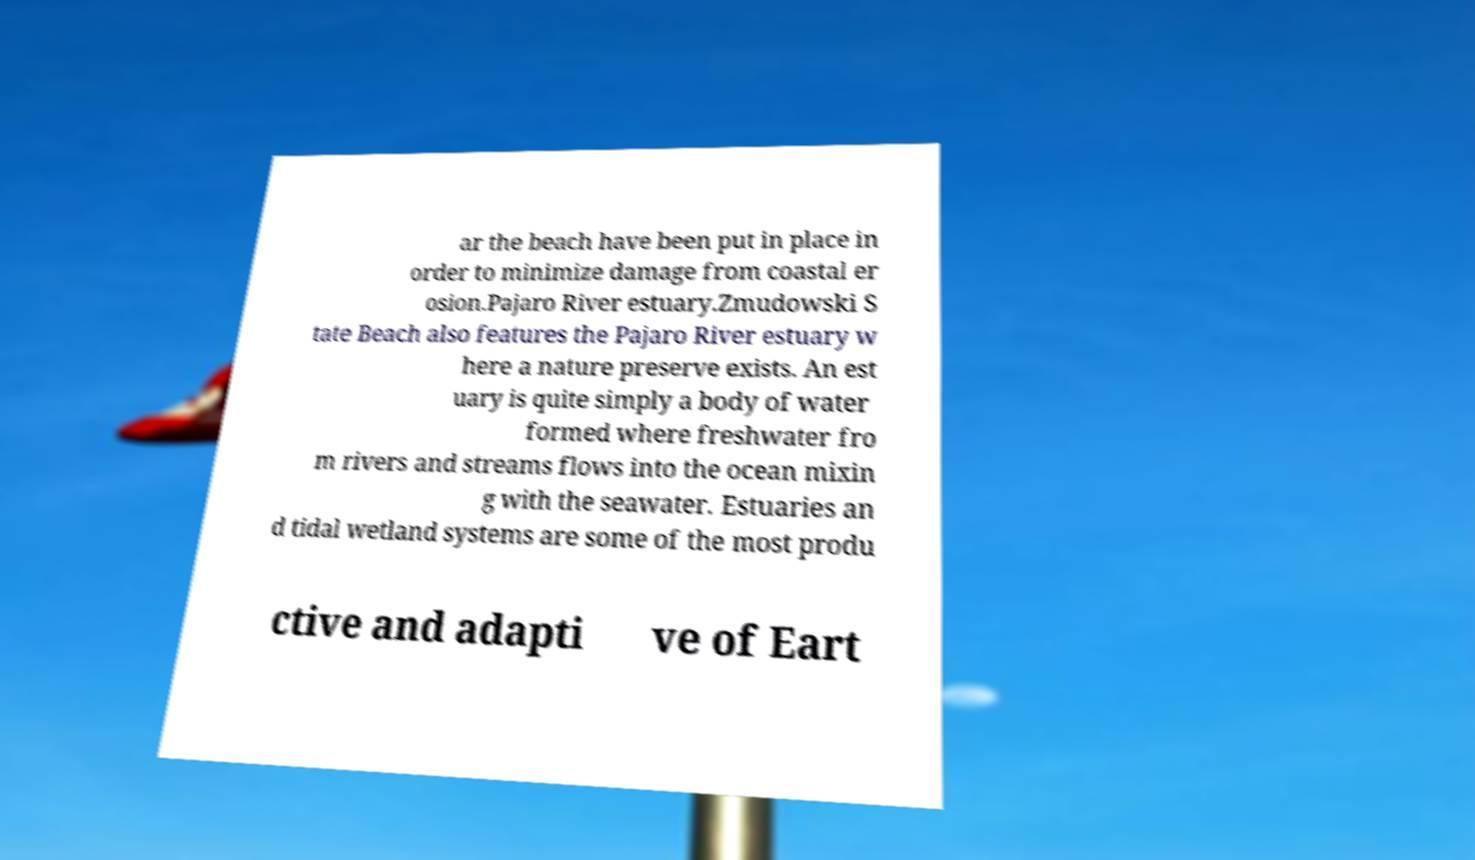Please read and relay the text visible in this image. What does it say? ar the beach have been put in place in order to minimize damage from coastal er osion.Pajaro River estuary.Zmudowski S tate Beach also features the Pajaro River estuary w here a nature preserve exists. An est uary is quite simply a body of water formed where freshwater fro m rivers and streams flows into the ocean mixin g with the seawater. Estuaries an d tidal wetland systems are some of the most produ ctive and adapti ve of Eart 